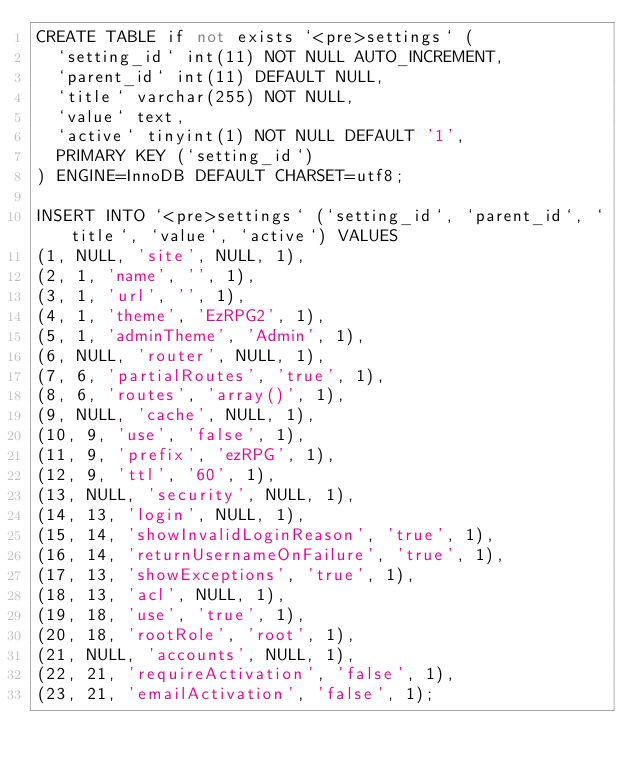Convert code to text. <code><loc_0><loc_0><loc_500><loc_500><_SQL_>CREATE TABLE if not exists `<pre>settings` (
  `setting_id` int(11) NOT NULL AUTO_INCREMENT,
  `parent_id` int(11) DEFAULT NULL,
  `title` varchar(255) NOT NULL,
  `value` text,
  `active` tinyint(1) NOT NULL DEFAULT '1',
  PRIMARY KEY (`setting_id`)
) ENGINE=InnoDB DEFAULT CHARSET=utf8;

INSERT INTO `<pre>settings` (`setting_id`, `parent_id`, `title`, `value`, `active`) VALUES
(1, NULL, 'site', NULL, 1),
(2, 1, 'name', '', 1),
(3, 1, 'url', '', 1),
(4, 1, 'theme', 'EzRPG2', 1),
(5, 1, 'adminTheme', 'Admin', 1),
(6, NULL, 'router', NULL, 1),
(7, 6, 'partialRoutes', 'true', 1),
(8, 6, 'routes', 'array()', 1),
(9, NULL, 'cache', NULL, 1),
(10, 9, 'use', 'false', 1),
(11, 9, 'prefix', 'ezRPG', 1),
(12, 9, 'ttl', '60', 1),
(13, NULL, 'security', NULL, 1),
(14, 13, 'login', NULL, 1),
(15, 14, 'showInvalidLoginReason', 'true', 1),
(16, 14, 'returnUsernameOnFailure', 'true', 1),
(17, 13, 'showExceptions', 'true', 1),
(18, 13, 'acl', NULL, 1),
(19, 18, 'use', 'true', 1),
(20, 18, 'rootRole', 'root', 1),
(21, NULL, 'accounts', NULL, 1),
(22, 21, 'requireActivation', 'false', 1),
(23, 21, 'emailActivation', 'false', 1);</code> 